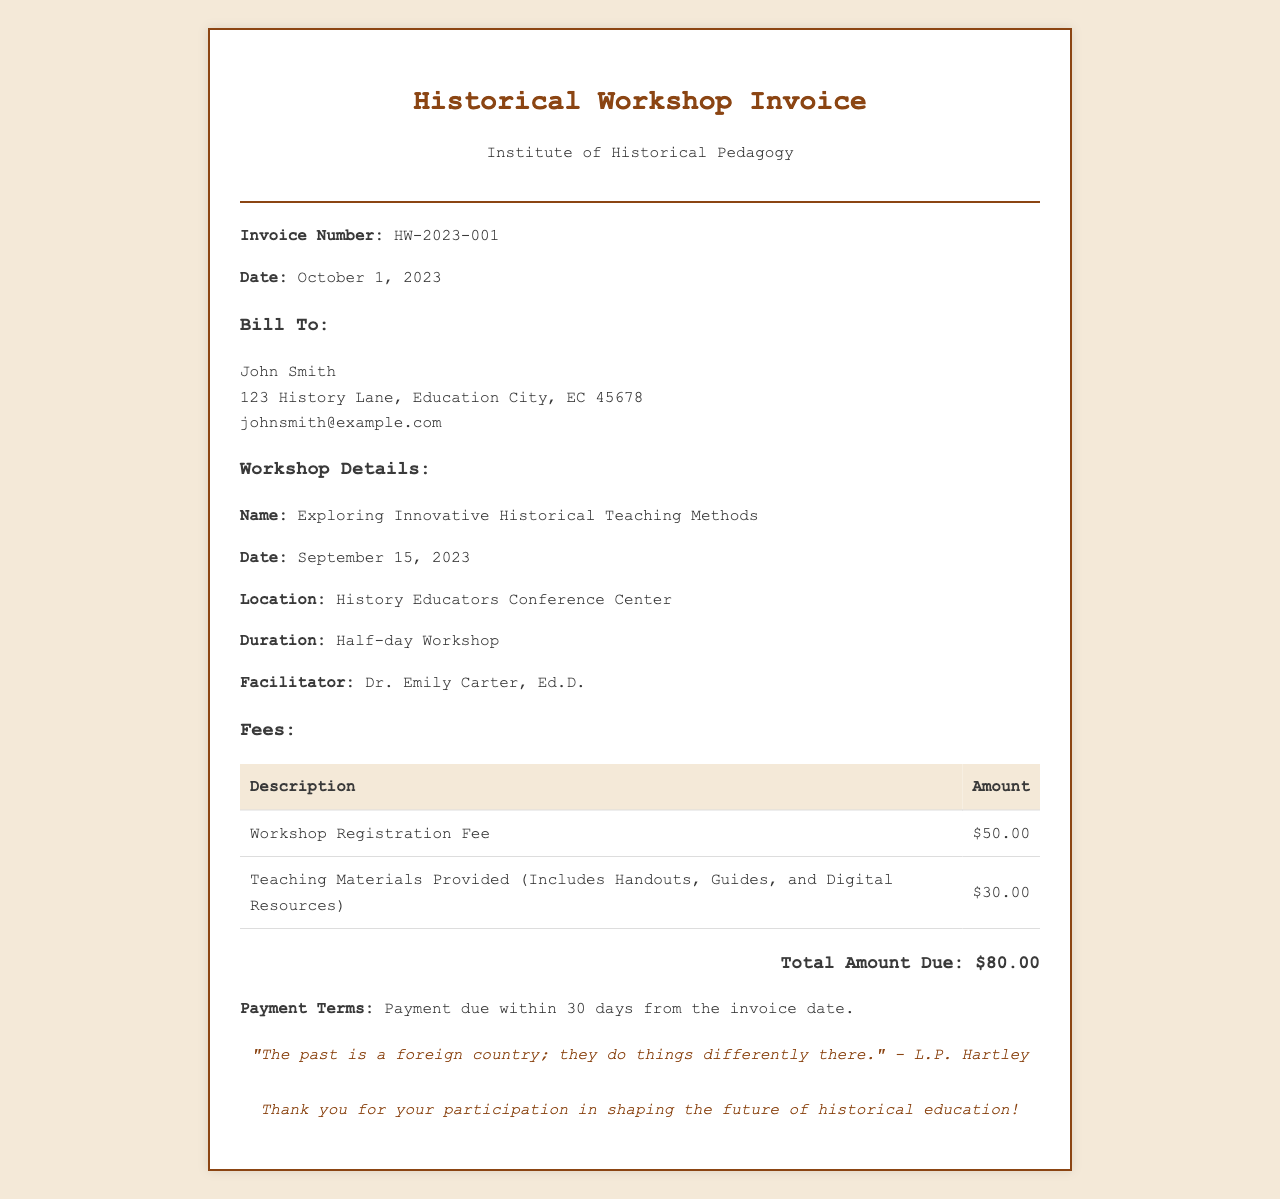What is the invoice number? The invoice number is a unique identifier for the document, listed in the invoice details.
Answer: HW-2023-001 Who is the facilitator of the workshop? The facilitator's name is mentioned in the workshop details section.
Answer: Dr. Emily Carter, Ed.D What is the total amount due? The total amount due is calculated from the fees listed in the invoice.
Answer: $80.00 What was the date of the workshop? The date of the workshop is provided in the workshop details.
Answer: September 15, 2023 What teaching materials were provided? The invoice specifies the types of teaching materials included in the fees.
Answer: Handouts, Guides, and Digital Resources What are the payment terms? The payment terms outline the time frame for completing the payment as indicated in the document.
Answer: Payment due within 30 days from the invoice date Where was the workshop held? The location of the workshop is specified in the workshop details section.
Answer: History Educators Conference Center 